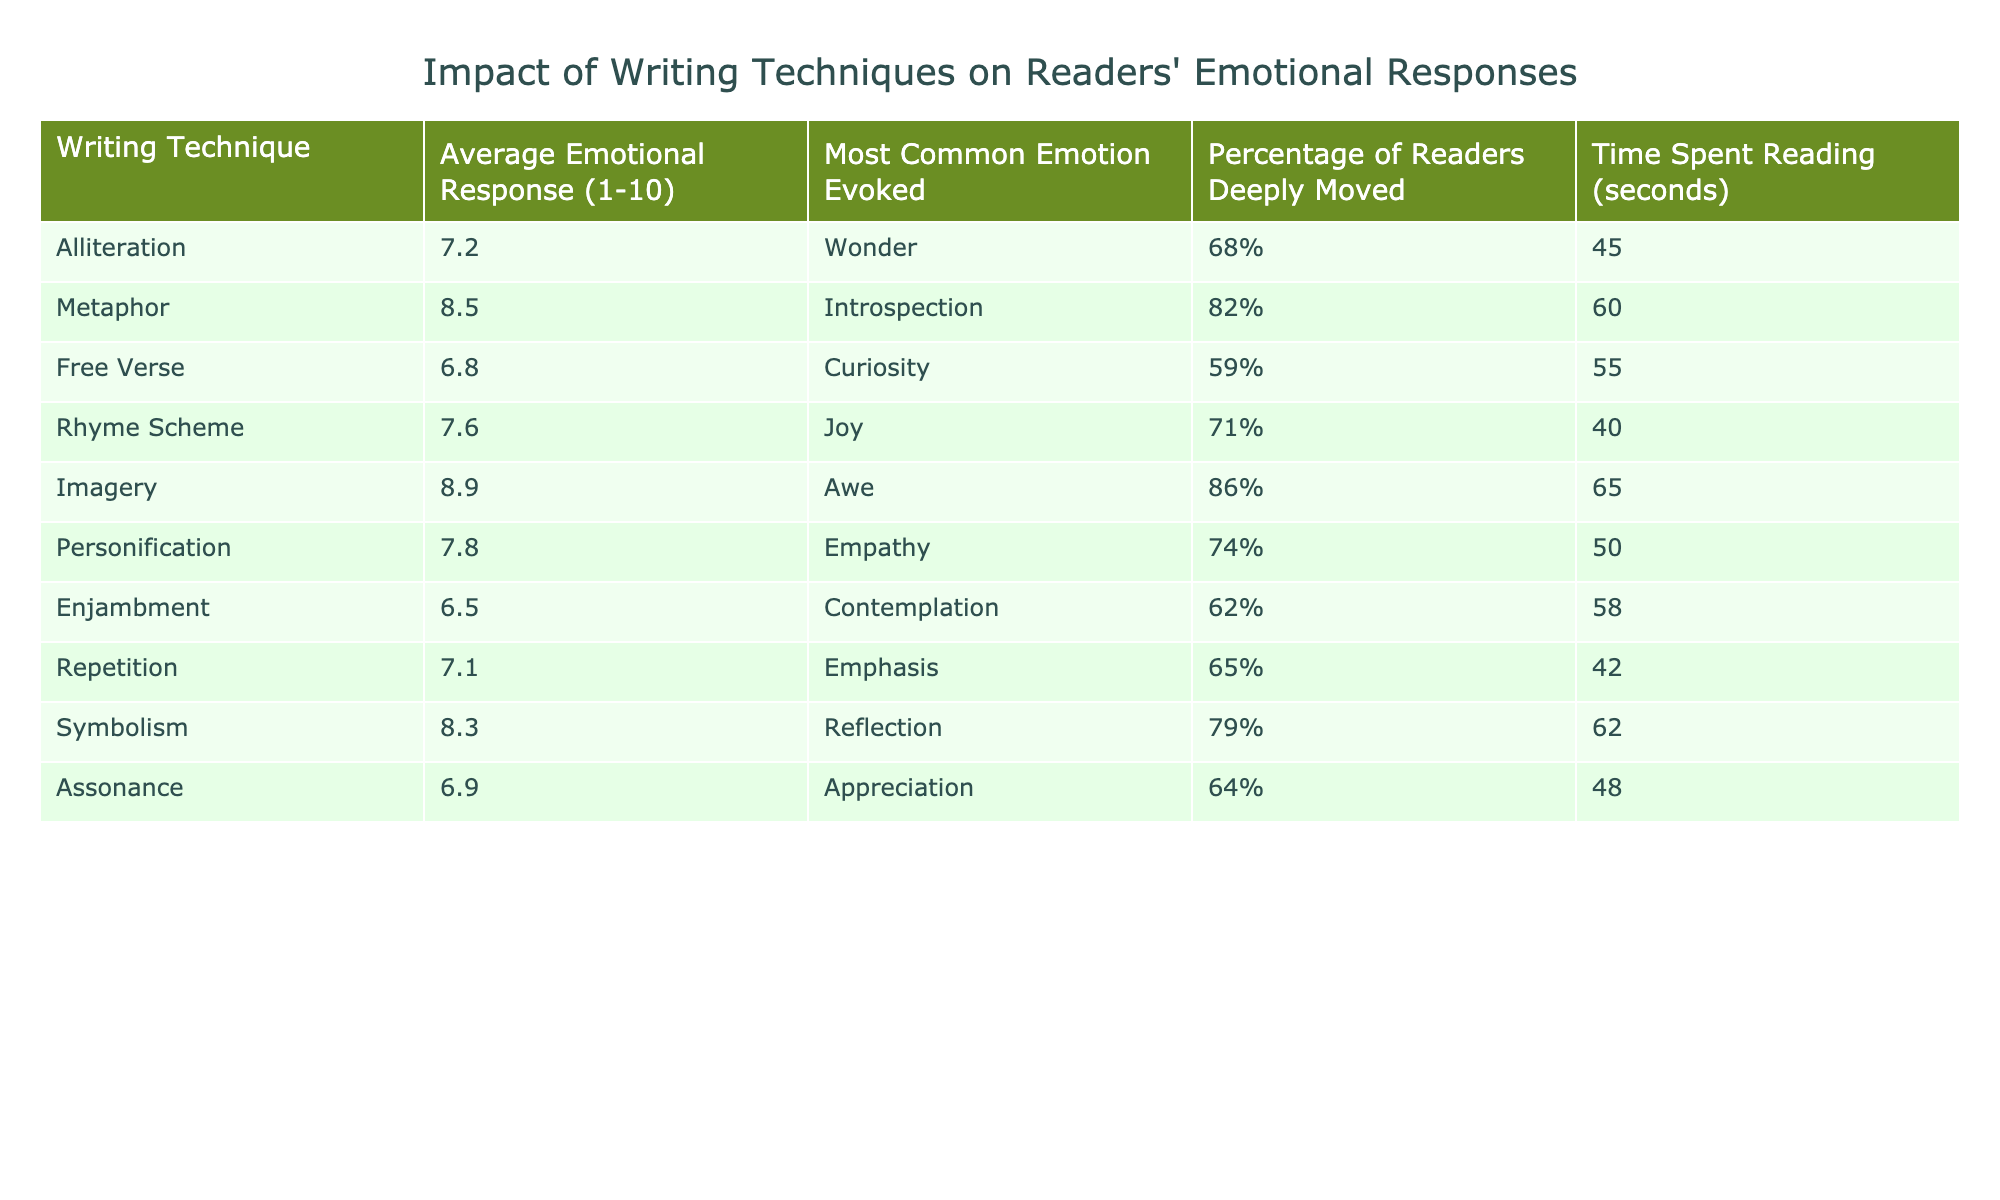What is the average emotional response for the technique of Imagery? Referring to the table, the average emotional response for Imagery is listed as 8.9.
Answer: 8.9 Which writing technique evokes the most common emotion of Wonder? The table shows that Alliteration evokes the most common emotion of Wonder.
Answer: Alliteration What is the percentage of readers that are deeply moved by Metaphor? Upon checking the table, the percentage of readers deeply moved by Metaphor is 82%.
Answer: 82% What is the average emotional response for Free Verse? The table indicates that the average emotional response for Free Verse is 6.8.
Answer: 6.8 Which technique has the highest percentage of readers deeply moved? According to the data, Imagery has the highest percentage of readers deeply moved, at 86%.
Answer: Imagery What is the most common emotion evoked by Symbolism? The most common emotion evoked by Symbolism, as per the table, is Reflection.
Answer: Reflection What is the difference between the average emotional response for Metaphor and Enjambment? The average emotional response for Metaphor is 8.5 and for Enjambment is 6.5. The difference is 8.5 - 6.5 = 2.
Answer: 2 Which writing technique has the lowest average emotional response? According to the table, Enjambment has the lowest average emotional response at 6.5.
Answer: Enjambment How much time, on average, do readers spend reading poetry that uses Assonance? The table states that readers spend an average of 48 seconds reading poetry that uses Assonance.
Answer: 48 seconds What is the average emotional response for techniques that evoke either Joy or Awe? The average emotional response for Rhyme Scheme (Joy) is 7.6 and for Imagery (Awe) is 8.9. The average of these two values is (7.6 + 8.9)/2 = 8.25.
Answer: 8.25 Which two techniques evoke the greatest emotional response, and what are those responses? The two techniques with the greatest emotional responses are Imagery (8.9) and Metaphor (8.5).
Answer: Imagery and Metaphor Are readers more deeply moved by Rhyme Scheme than by Free Verse? For Rhyme Scheme, 71% of readers are deeply moved, while for Free Verse, it is 59%. Therefore, yes, readers are more deeply moved by Rhyme Scheme.
Answer: Yes What writing technique has an average emotional response above 8, and what emotion does it evoke? The techniques with an average response above 8 are Imagery (Awe), Metaphor (Introspection), and Symbolism (Reflection).
Answer: Imagery, Metaphor, and Symbolism 